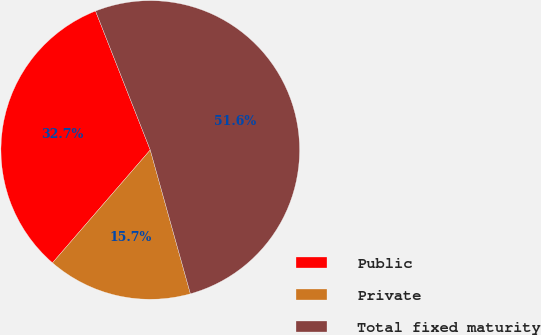<chart> <loc_0><loc_0><loc_500><loc_500><pie_chart><fcel>Public<fcel>Private<fcel>Total fixed maturity<nl><fcel>32.67%<fcel>15.69%<fcel>51.64%<nl></chart> 